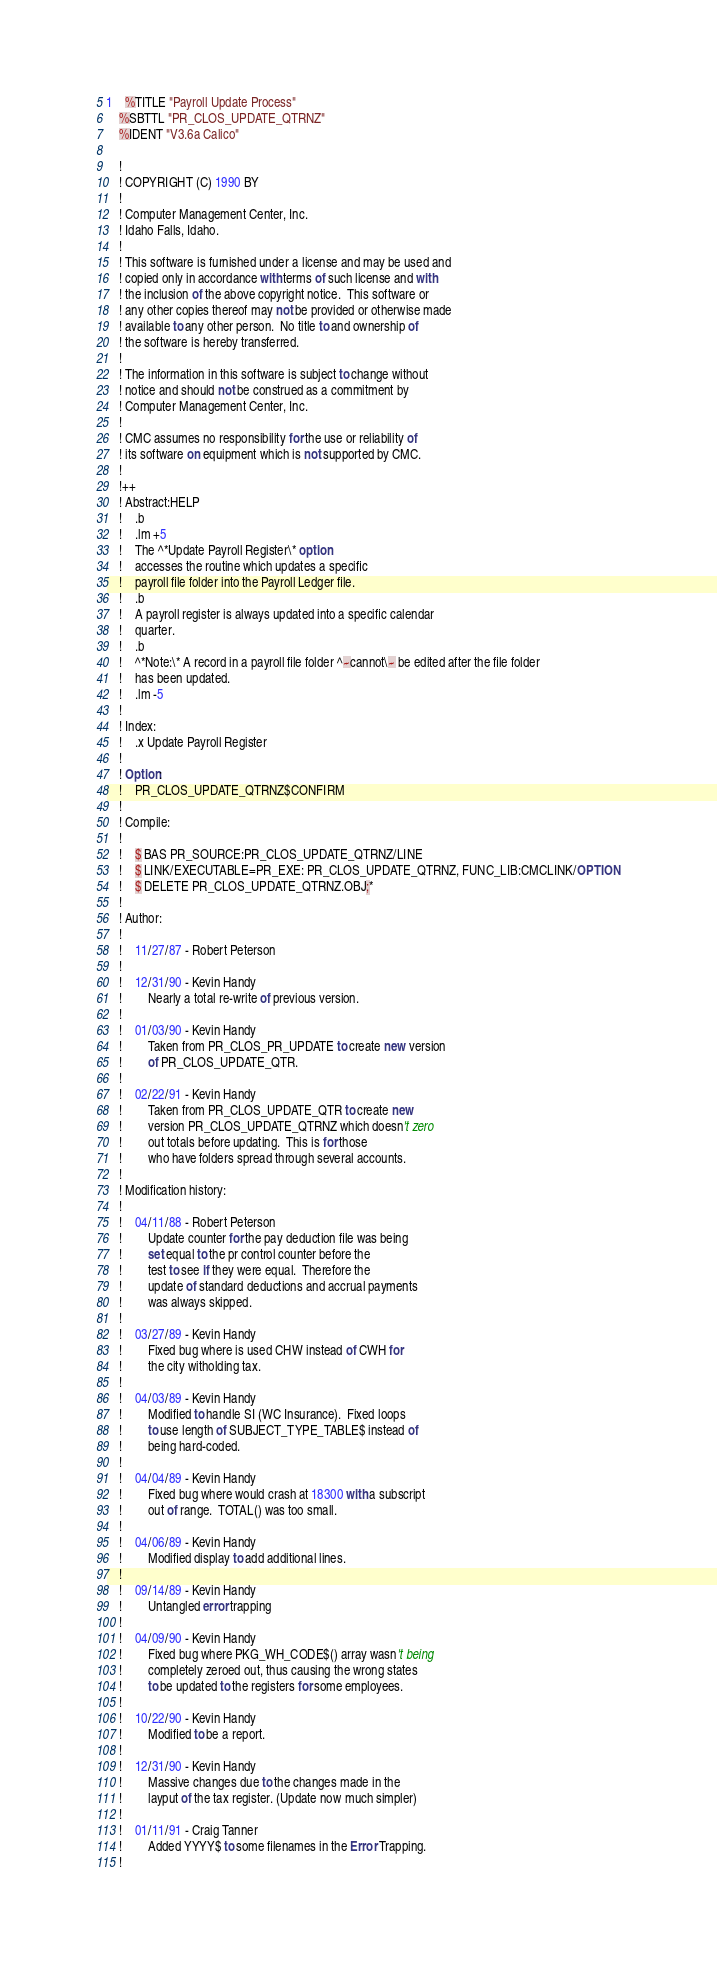<code> <loc_0><loc_0><loc_500><loc_500><_VisualBasic_>1	%TITLE "Payroll Update Process"
	%SBTTL "PR_CLOS_UPDATE_QTRNZ"
	%IDENT "V3.6a Calico"

	!
	! COPYRIGHT (C) 1990 BY
	!
	! Computer Management Center, Inc.
	! Idaho Falls, Idaho.
	!
	! This software is furnished under a license and may be used and
	! copied only in accordance with terms of such license and with
	! the inclusion of the above copyright notice.  This software or
	! any other copies thereof may not be provided or otherwise made
	! available to any other person.  No title to and ownership of
	! the software is hereby transferred.
	!
	! The information in this software is subject to change without
	! notice and should not be construed as a commitment by
	! Computer Management Center, Inc.
	!
	! CMC assumes no responsibility for the use or reliability of
	! its software on equipment which is not supported by CMC.
	!
	!++
	! Abstract:HELP
	!	.b
	!	.lm +5
	!	The ^*Update Payroll Register\* option
	!	accesses the routine which updates a specific
	!	payroll file folder into the Payroll Ledger file.
	!	.b
	!	A payroll register is always updated into a specific calendar
	!	quarter.
	!	.b
	!	^*Note:\* A record in a payroll file folder ^~cannot\~ be edited after the file folder
	!	has been updated.
	!	.lm -5
	!
	! Index:
	!	.x Update Payroll Register
	!
	! Option:
	!	PR_CLOS_UPDATE_QTRNZ$CONFIRM
	!
	! Compile:
	!
	!	$ BAS PR_SOURCE:PR_CLOS_UPDATE_QTRNZ/LINE
	!	$ LINK/EXECUTABLE=PR_EXE: PR_CLOS_UPDATE_QTRNZ, FUNC_LIB:CMCLINK/OPTION
	!	$ DELETE PR_CLOS_UPDATE_QTRNZ.OBJ;*
	!
	! Author:
	!
	!	11/27/87 - Robert Peterson
	!
	!	12/31/90 - Kevin Handy
	!		Nearly a total re-write of previous version.
	!
	!	01/03/90 - Kevin Handy
	!		Taken from PR_CLOS_PR_UPDATE to create new version
	!		of PR_CLOS_UPDATE_QTR.
	!
	!	02/22/91 - Kevin Handy
	!		Taken from PR_CLOS_UPDATE_QTR to create new
	!		version PR_CLOS_UPDATE_QTRNZ which doesn't zero
	!		out totals before updating.  This is for those
	!		who have folders spread through several accounts.
	!
	! Modification history:
	!
	!	04/11/88 - Robert Peterson
	!		Update counter for the pay deduction file was being
	!		set equal to the pr control counter before the
	!		test to see if they were equal.  Therefore the
	!		update of standard deductions and accrual payments
	!		was always skipped.
	!
	!	03/27/89 - Kevin Handy
	!		Fixed bug where is used CHW instead of CWH for
	!		the city witholding tax.
	!
	!	04/03/89 - Kevin Handy
	!		Modified to handle SI (WC Insurance).  Fixed loops
	!		to use length of SUBJECT_TYPE_TABLE$ instead of
	!		being hard-coded.
	!
	!	04/04/89 - Kevin Handy
	!		Fixed bug where would crash at 18300 with a subscript
	!		out of range.  TOTAL() was too small.
	!
	!	04/06/89 - Kevin Handy
	!		Modified display to add additional lines.
	!
	!	09/14/89 - Kevin Handy
	!		Untangled error trapping
	!
	!	04/09/90 - Kevin Handy
	!		Fixed bug where PKG_WH_CODE$() array wasn't being
	!		completely zeroed out, thus causing the wrong states
	!		to be updated to the registers for some employees.
	!
	!	10/22/90 - Kevin Handy
	!		Modified to be a report.
	!
	!	12/31/90 - Kevin Handy
	!		Massive changes due to the changes made in the
	!		layput of the tax register. (Update now much simpler)
	!
	!	01/11/91 - Craig Tanner
	!		Added YYYY$ to some filenames in the Error Trapping.
	!</code> 